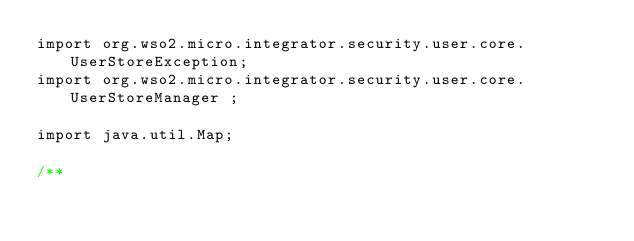Convert code to text. <code><loc_0><loc_0><loc_500><loc_500><_Java_>import org.wso2.micro.integrator.security.user.core.UserStoreException;
import org.wso2.micro.integrator.security.user.core.UserStoreManager ;

import java.util.Map;

/**</code> 